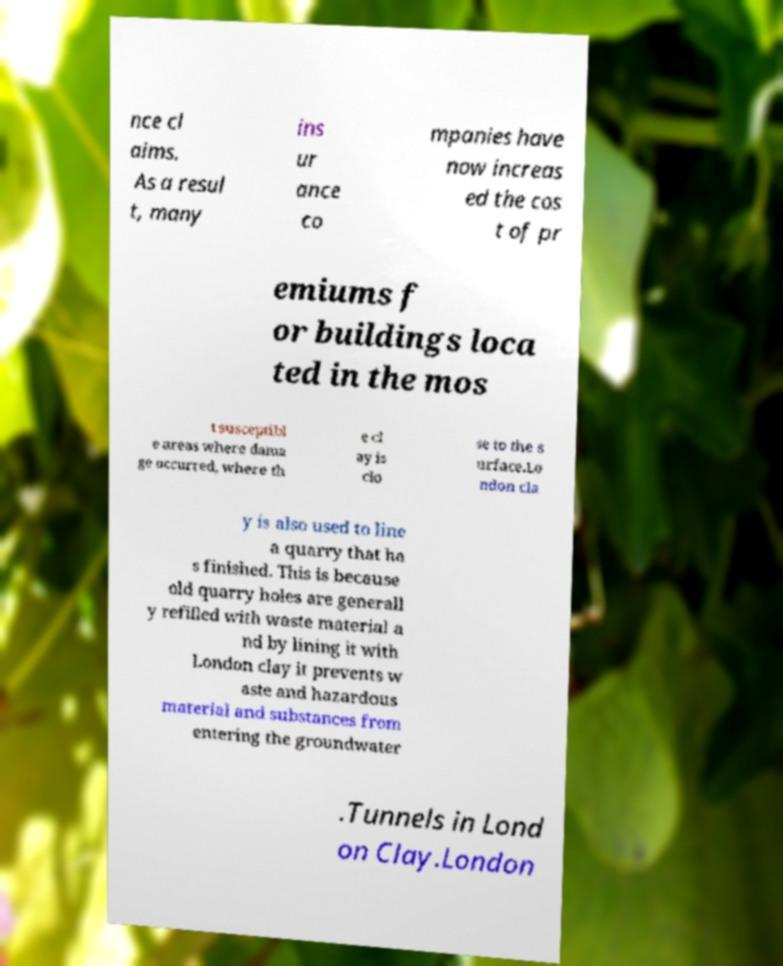Please read and relay the text visible in this image. What does it say? nce cl aims. As a resul t, many ins ur ance co mpanies have now increas ed the cos t of pr emiums f or buildings loca ted in the mos t susceptibl e areas where dama ge occurred, where th e cl ay is clo se to the s urface.Lo ndon cla y is also used to line a quarry that ha s finished. This is because old quarry holes are generall y refilled with waste material a nd by lining it with London clay it prevents w aste and hazardous material and substances from entering the groundwater .Tunnels in Lond on Clay.London 